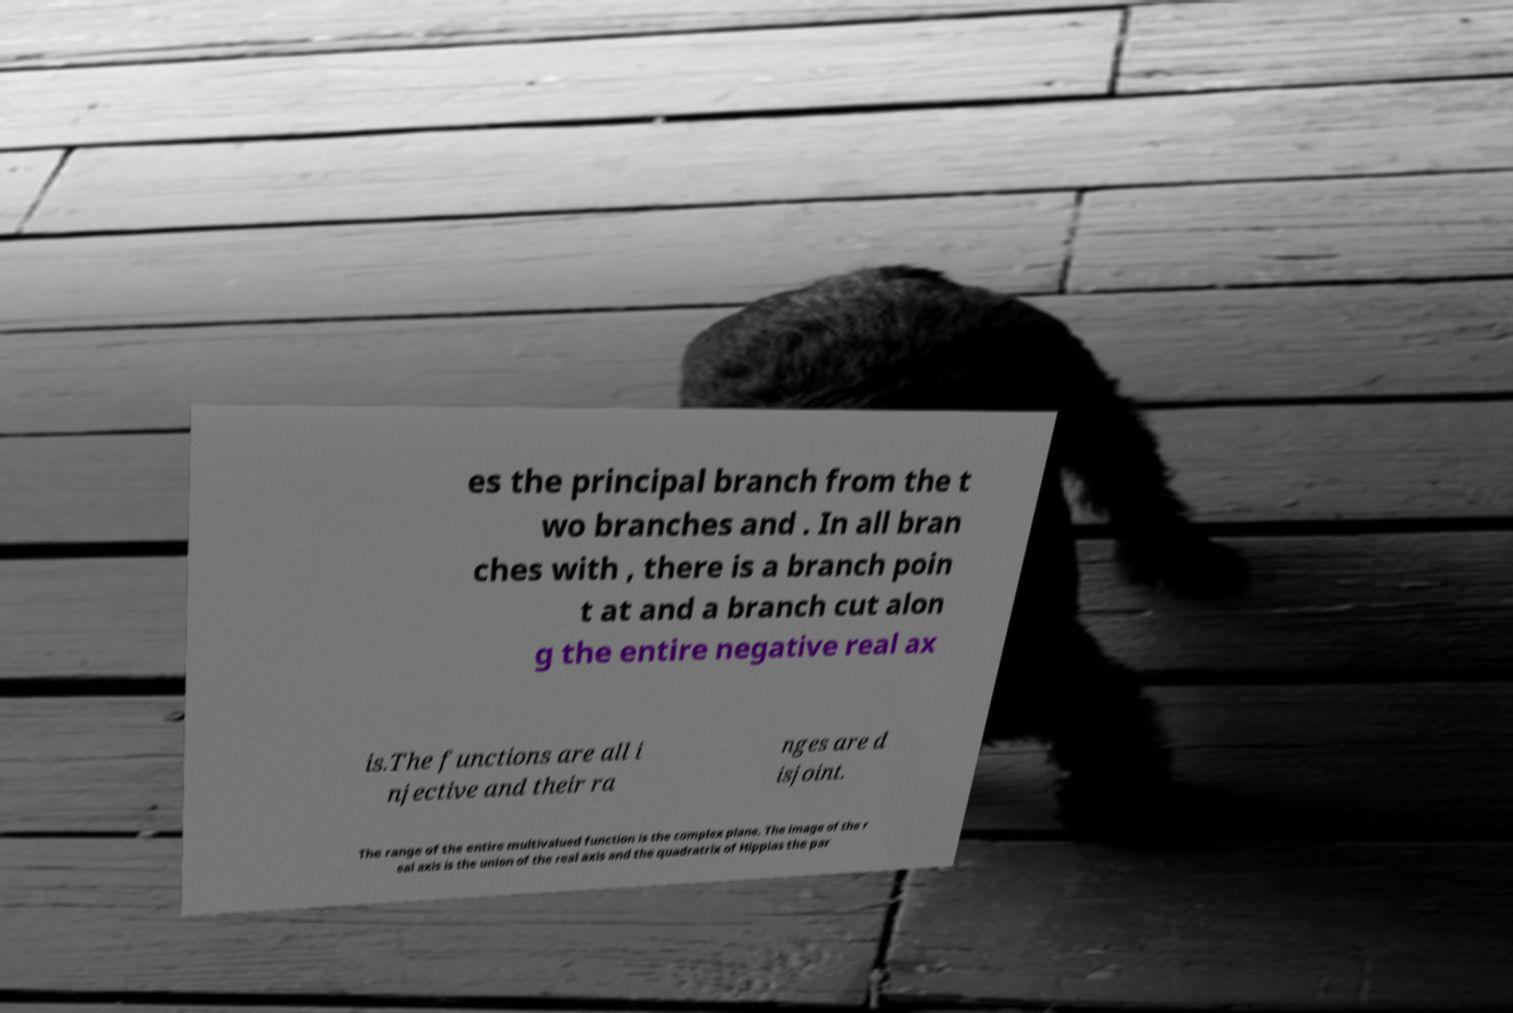What messages or text are displayed in this image? I need them in a readable, typed format. es the principal branch from the t wo branches and . In all bran ches with , there is a branch poin t at and a branch cut alon g the entire negative real ax is.The functions are all i njective and their ra nges are d isjoint. The range of the entire multivalued function is the complex plane. The image of the r eal axis is the union of the real axis and the quadratrix of Hippias the par 